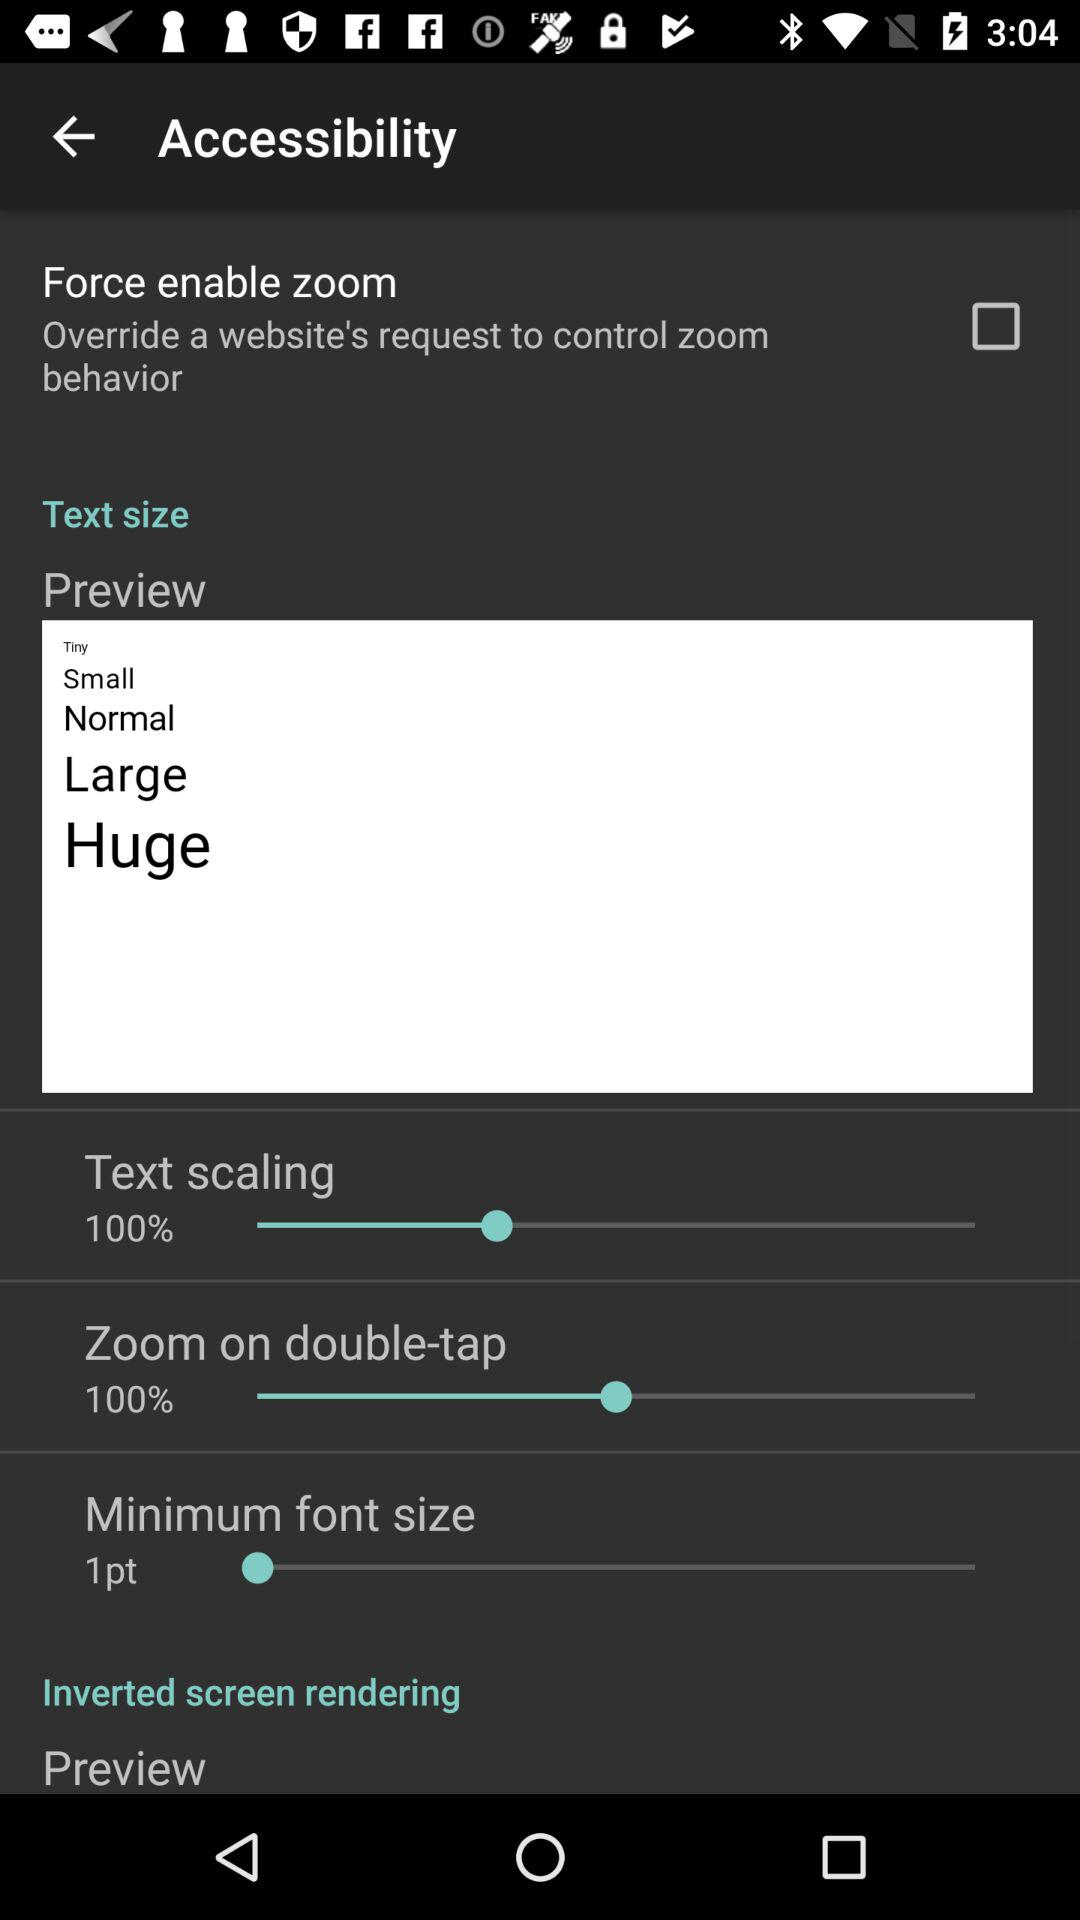What is the maximum font size in points?
When the provided information is insufficient, respond with <no answer>. <no answer> 